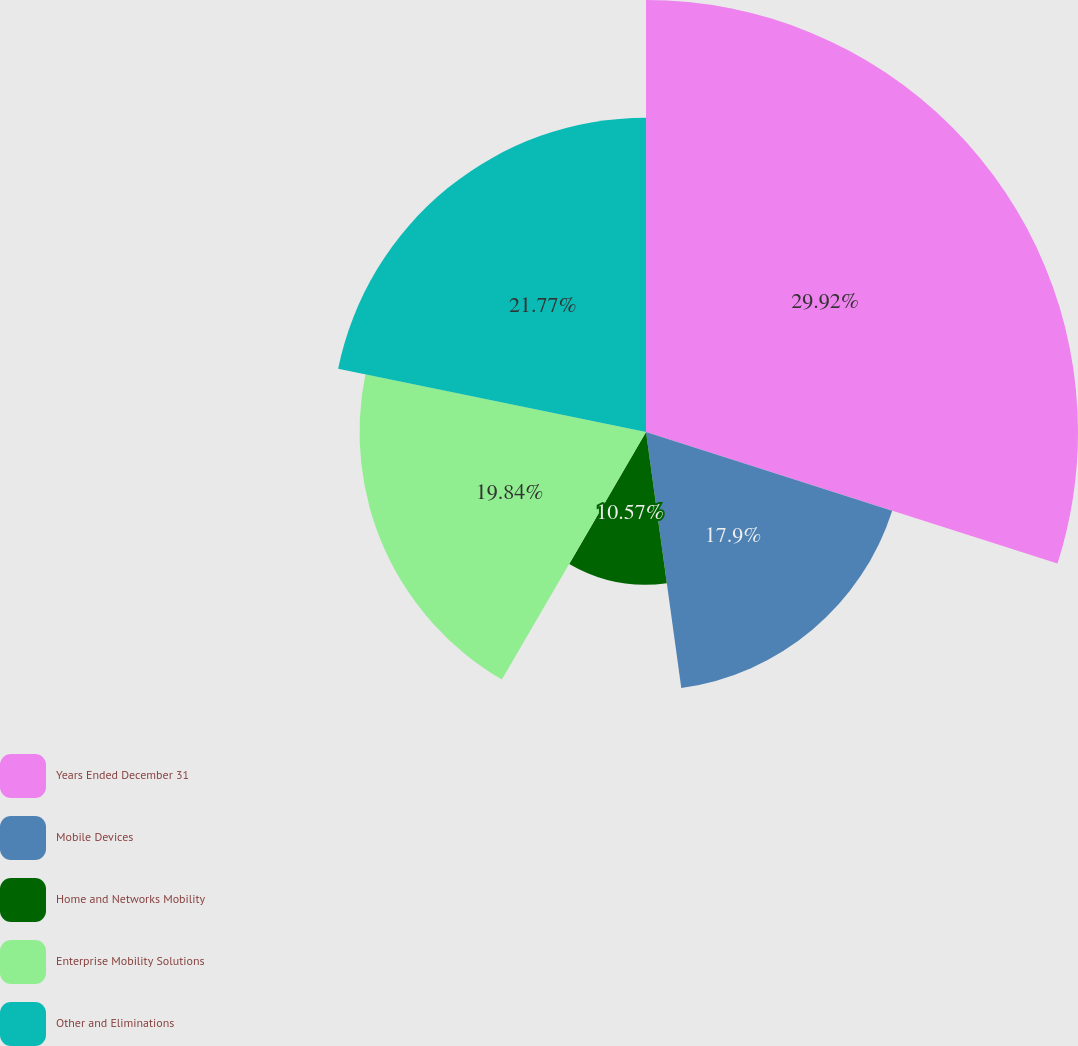Convert chart. <chart><loc_0><loc_0><loc_500><loc_500><pie_chart><fcel>Years Ended December 31<fcel>Mobile Devices<fcel>Home and Networks Mobility<fcel>Enterprise Mobility Solutions<fcel>Other and Eliminations<nl><fcel>29.92%<fcel>17.9%<fcel>10.57%<fcel>19.84%<fcel>21.77%<nl></chart> 